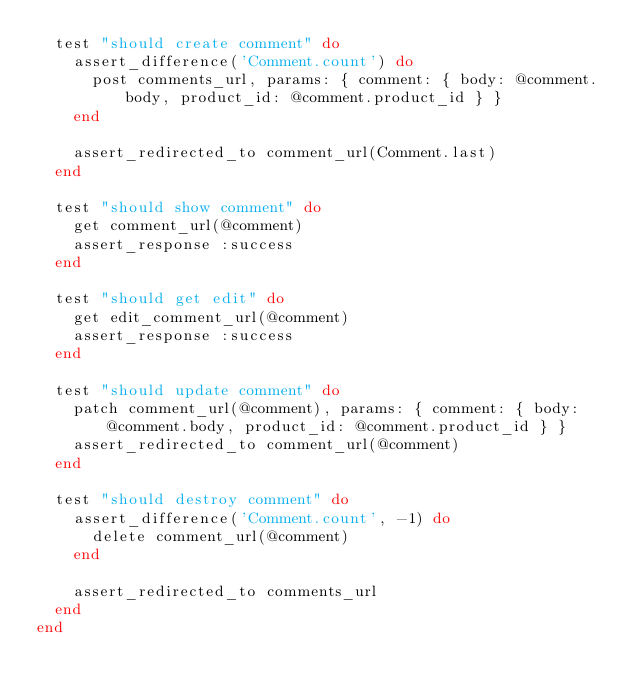<code> <loc_0><loc_0><loc_500><loc_500><_Ruby_>  test "should create comment" do
    assert_difference('Comment.count') do
      post comments_url, params: { comment: { body: @comment.body, product_id: @comment.product_id } }
    end

    assert_redirected_to comment_url(Comment.last)
  end

  test "should show comment" do
    get comment_url(@comment)
    assert_response :success
  end

  test "should get edit" do
    get edit_comment_url(@comment)
    assert_response :success
  end

  test "should update comment" do
    patch comment_url(@comment), params: { comment: { body: @comment.body, product_id: @comment.product_id } }
    assert_redirected_to comment_url(@comment)
  end

  test "should destroy comment" do
    assert_difference('Comment.count', -1) do
      delete comment_url(@comment)
    end

    assert_redirected_to comments_url
  end
end
</code> 